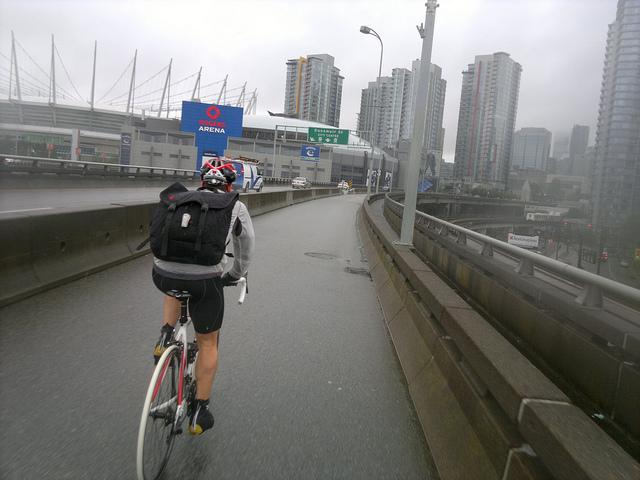Is it a sunny day?
Be succinct. No. What color is his backpack?
Keep it brief. Black. How many signs are in the picture?
Concise answer only. 3. What is the man wearing on his head?
Short answer required. Helmet. 